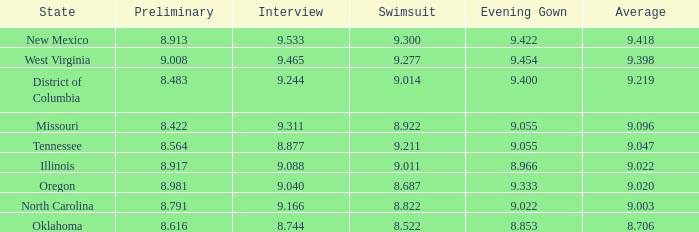Determine the bathing suit for oregon. 8.687. 